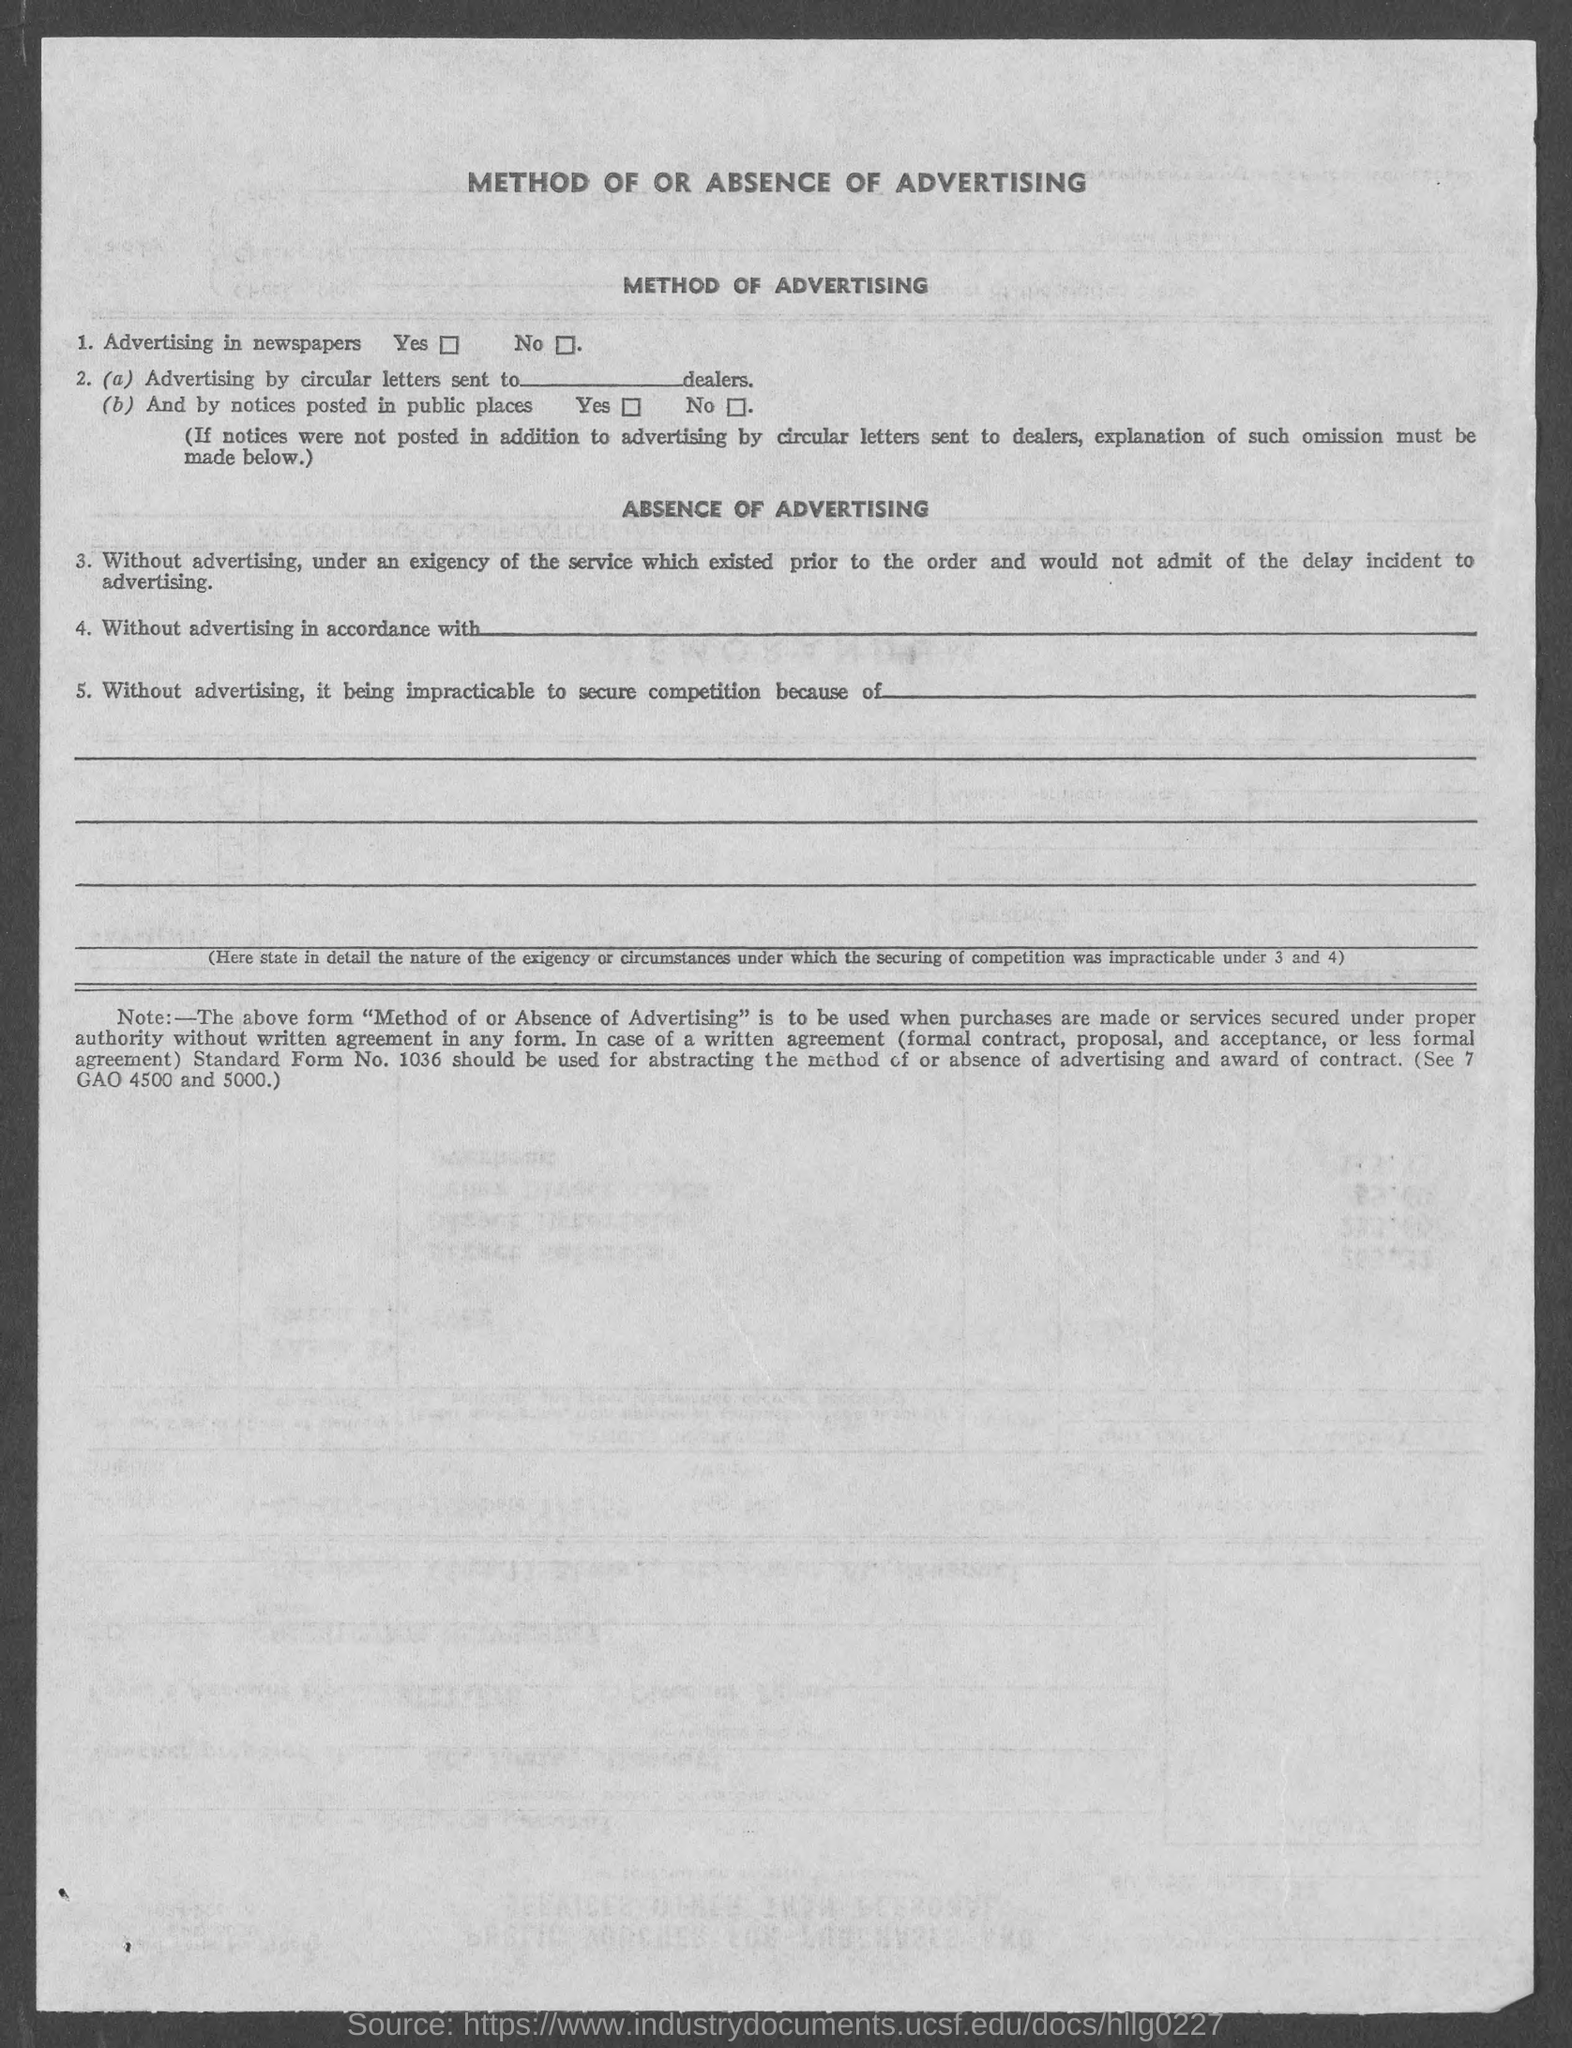What is the document title?
Offer a terse response. METHOD OF OR ABSENCE OF ADVERTISING. 